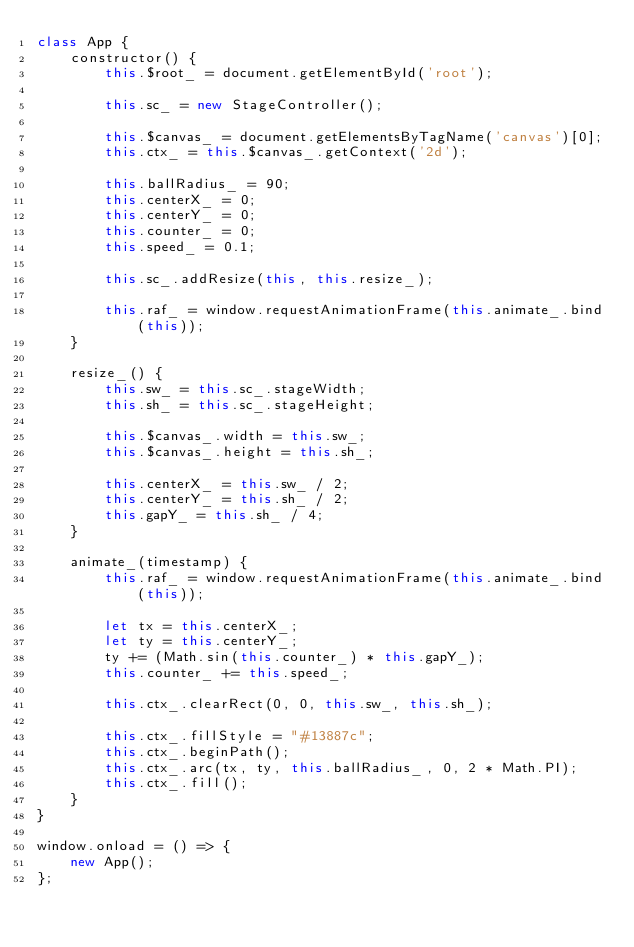Convert code to text. <code><loc_0><loc_0><loc_500><loc_500><_JavaScript_>class App {
    constructor() {
        this.$root_ = document.getElementById('root');

        this.sc_ = new StageController();

        this.$canvas_ = document.getElementsByTagName('canvas')[0];
        this.ctx_ = this.$canvas_.getContext('2d');

        this.ballRadius_ = 90;
        this.centerX_ = 0;
        this.centerY_ = 0;
        this.counter_ = 0;
        this.speed_ = 0.1;

        this.sc_.addResize(this, this.resize_);

        this.raf_ = window.requestAnimationFrame(this.animate_.bind(this));
    }

    resize_() {
        this.sw_ = this.sc_.stageWidth;
        this.sh_ = this.sc_.stageHeight;

        this.$canvas_.width = this.sw_;
        this.$canvas_.height = this.sh_;

        this.centerX_ = this.sw_ / 2;
        this.centerY_ = this.sh_ / 2;
        this.gapY_ = this.sh_ / 4;
    }

    animate_(timestamp) {
        this.raf_ = window.requestAnimationFrame(this.animate_.bind(this));

        let tx = this.centerX_;
        let ty = this.centerY_;
        ty += (Math.sin(this.counter_) * this.gapY_);
        this.counter_ += this.speed_;

        this.ctx_.clearRect(0, 0, this.sw_, this.sh_);

        this.ctx_.fillStyle = "#13887c";
        this.ctx_.beginPath();
        this.ctx_.arc(tx, ty, this.ballRadius_, 0, 2 * Math.PI);
        this.ctx_.fill();
    }
}

window.onload = () => {
    new App();
};
</code> 